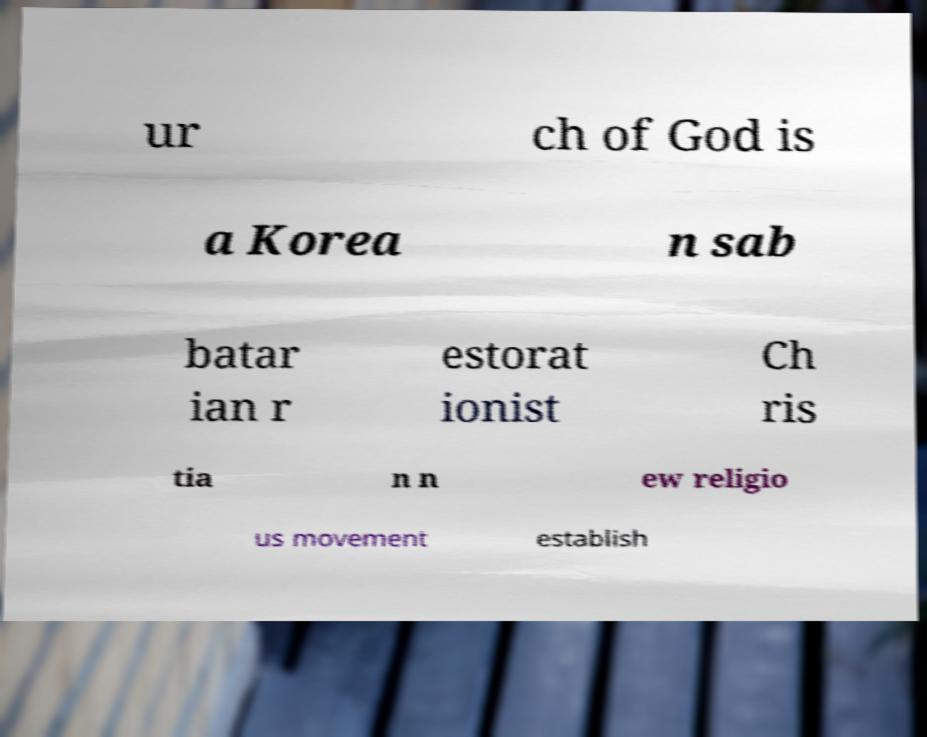I need the written content from this picture converted into text. Can you do that? ur ch of God is a Korea n sab batar ian r estorat ionist Ch ris tia n n ew religio us movement establish 